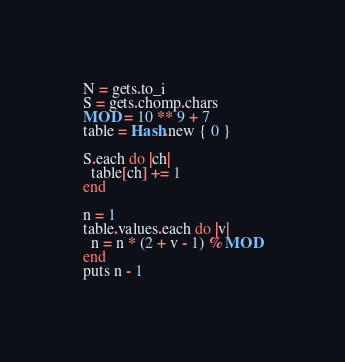Convert code to text. <code><loc_0><loc_0><loc_500><loc_500><_Ruby_>N = gets.to_i
S = gets.chomp.chars
MOD = 10 ** 9 + 7
table = Hash.new { 0 }

S.each do |ch|
  table[ch] += 1
end

n = 1
table.values.each do |v|
  n = n * (2 + v - 1) % MOD
end
puts n - 1
</code> 